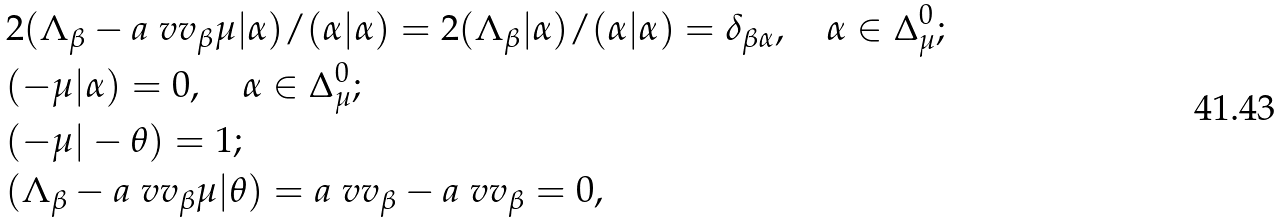<formula> <loc_0><loc_0><loc_500><loc_500>& 2 ( \Lambda _ { \beta } - a ^ { \ } v v _ { \beta } \mu | \alpha ) / ( \alpha | \alpha ) = 2 ( \Lambda _ { \beta } | \alpha ) / ( \alpha | \alpha ) = \delta _ { \beta \alpha } , \quad \alpha \in \Delta ^ { 0 } _ { \mu } ; \\ & ( - \mu | \alpha ) = 0 , \quad \alpha \in \Delta ^ { 0 } _ { \mu } ; \\ & ( - \mu | - \theta ) = 1 ; \\ & ( \Lambda _ { \beta } - a ^ { \ } v v _ { \beta } \mu | \theta ) = a ^ { \ } v v _ { \beta } - a ^ { \ } v v _ { \beta } = 0 ,</formula> 